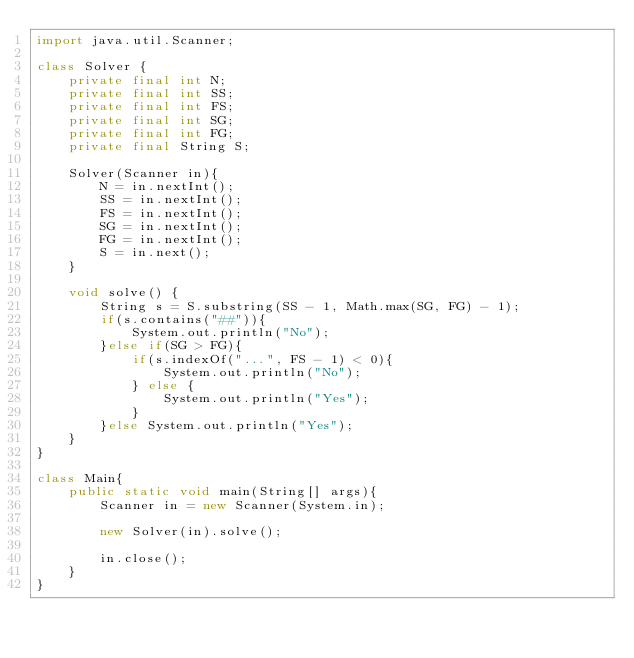<code> <loc_0><loc_0><loc_500><loc_500><_Java_>import java.util.Scanner;

class Solver {
    private final int N;
    private final int SS;
    private final int FS;
    private final int SG;
    private final int FG;
    private final String S;

    Solver(Scanner in){
        N = in.nextInt();
        SS = in.nextInt();
        FS = in.nextInt();
        SG = in.nextInt();
        FG = in.nextInt();
        S = in.next();
    }

    void solve() {
        String s = S.substring(SS - 1, Math.max(SG, FG) - 1);
        if(s.contains("##")){
            System.out.println("No");
        }else if(SG > FG){
            if(s.indexOf("...", FS - 1) < 0){
                System.out.println("No");
            } else {
                System.out.println("Yes");
            }
        }else System.out.println("Yes");
    }
}

class Main{
    public static void main(String[] args){
        Scanner in = new Scanner(System.in);

        new Solver(in).solve();

        in.close();
    }
}</code> 